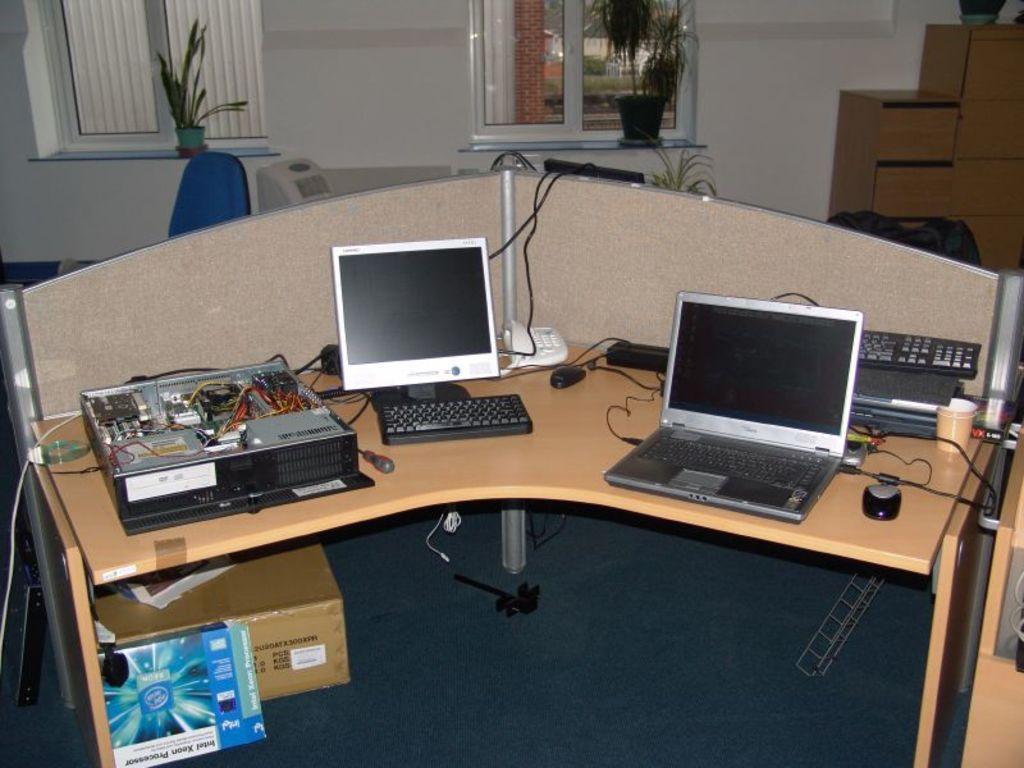Can you describe this image briefly? In this image, we can see laptops, keyboards, mouses and some other cables and objects are on the table. In the background, there are windows, flower pots, boxes and a chair and there are some other objects. At the bottom, there are boxes on the floor. 